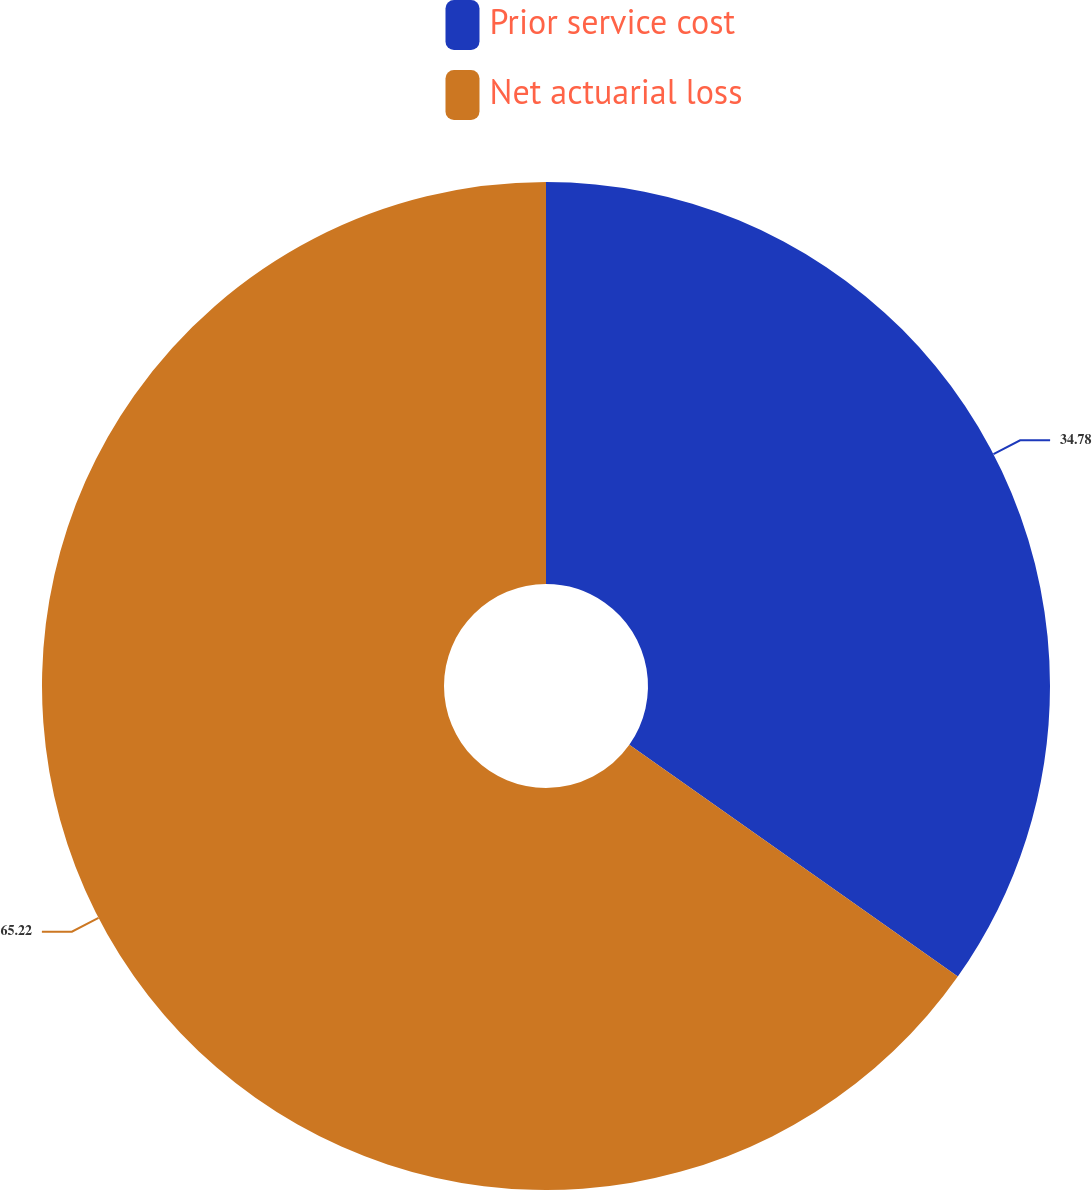<chart> <loc_0><loc_0><loc_500><loc_500><pie_chart><fcel>Prior service cost<fcel>Net actuarial loss<nl><fcel>34.78%<fcel>65.22%<nl></chart> 